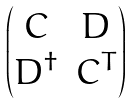<formula> <loc_0><loc_0><loc_500><loc_500>\begin{pmatrix} C & D \\ { D } ^ { \dag } & { C } ^ { T } \end{pmatrix}</formula> 